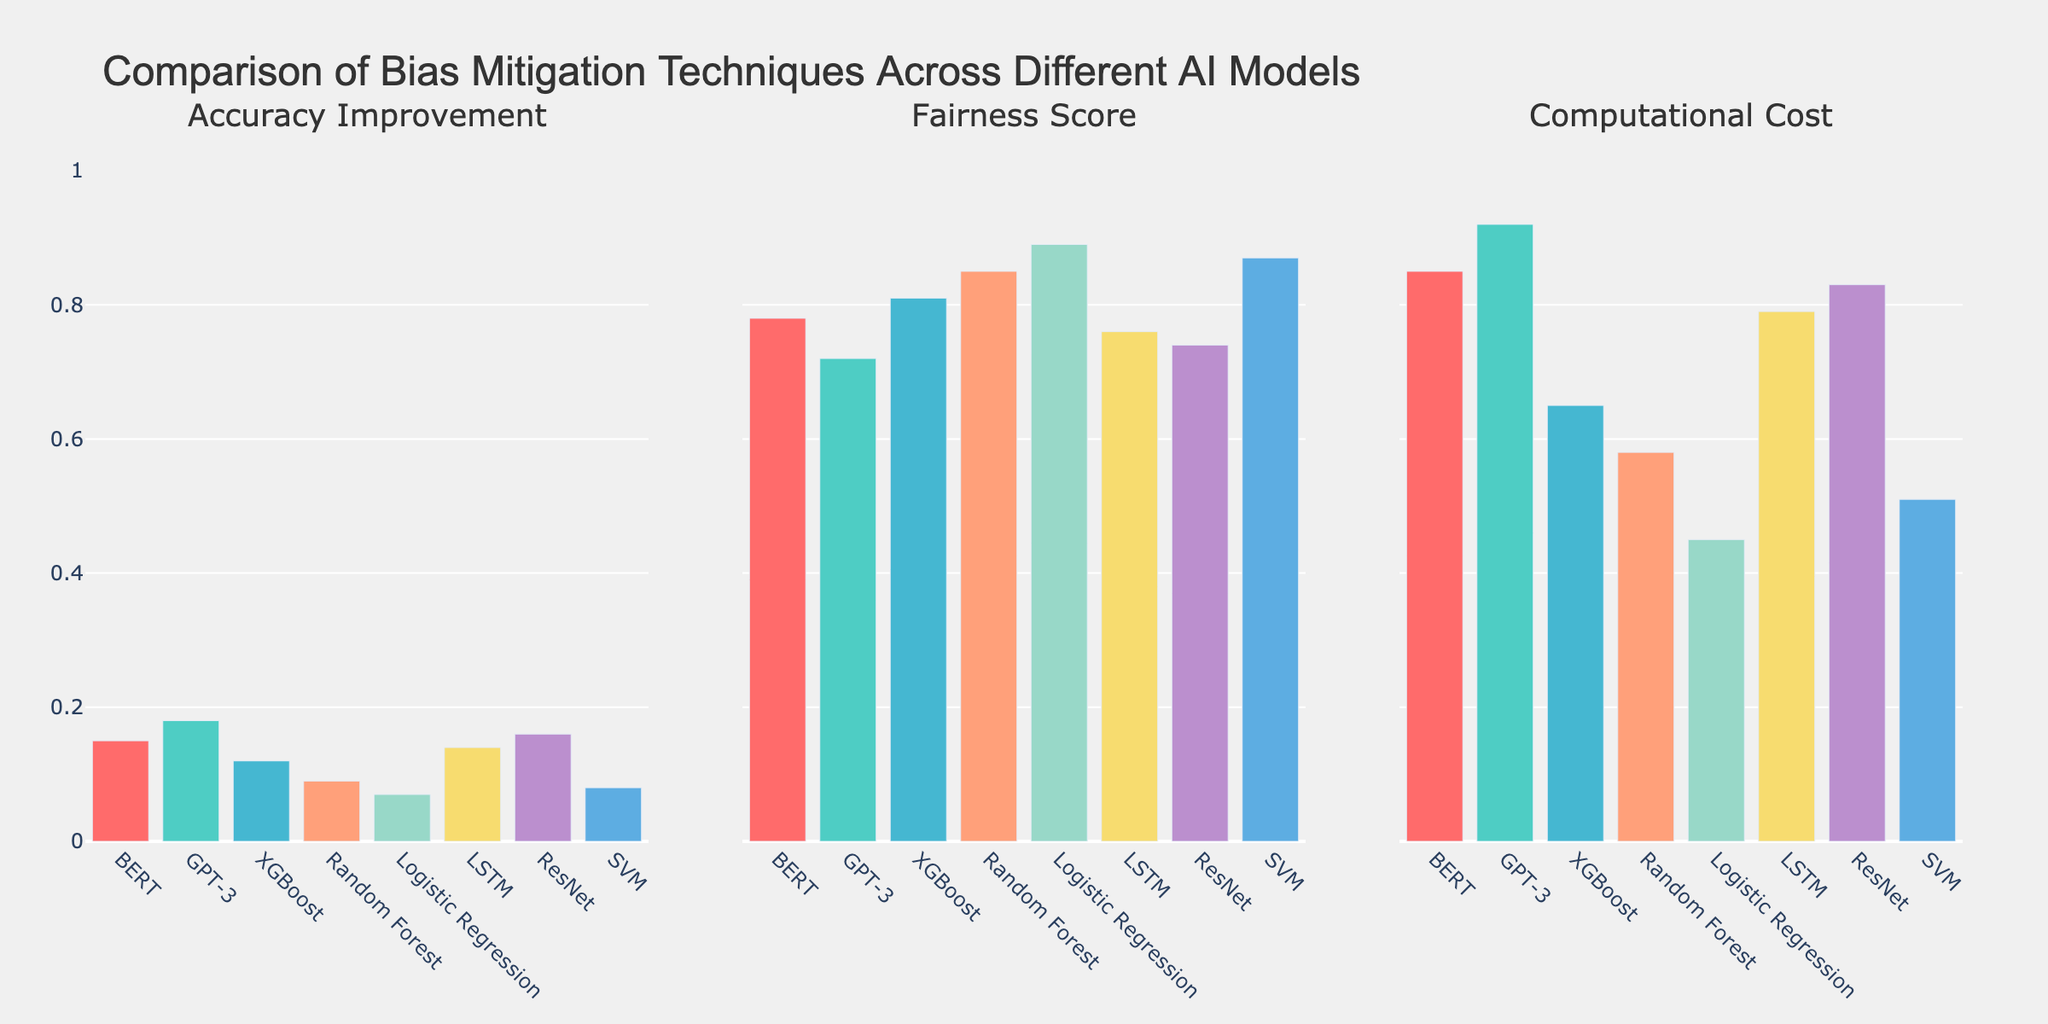Which AI model has the highest accuracy improvement? The BERT, GPT-3, ResNet, and LSTM bars are near the top of the "Accuracy Improvement" subplot. Comparing their heights, GPT-3 has the highest.
Answer: GPT-3 Which model has the lowest computational cost? Looking at the "Computational Cost" subplot, the bar for Logistic Regression is the shortest.
Answer: Logistic Regression How do the fairness scores compare between Logistic Regression and Random Forest? In the "Fairness Score" subplot, the bars for Logistic Regression and Random Forest are the highest and nearly the same, with Logistic Regression slightly higher.
Answer: Logistic Regression slightly higher What is the difference in fairness scores between SVM and BERT? The "Fairness Score" subplot shows that SVM has a fairness score of 0.87, while BERT has 0.78. Subtracting 0.78 from 0.87 gives 0.09.
Answer: 0.09 Which model has a higher accuracy improvement: XGBoost or LSTM? In the "Accuracy Improvement" subplot, the bar for LSTM is taller than that for XGBoost.
Answer: LSTM What is the average computational cost of BERT, GPT-3, and ResNet? The computational costs for BERT, GPT-3, and ResNet are 0.85, 0.92, and 0.83, respectively. The sum is 2.60. Dividing 2.60 by 3 gives approximately 0.867.
Answer: 0.867 What is the total number of models analyzed in the plot? Each subplot contains bars for the same number of models. Counting the bars, there are 8 models.
Answer: 8 Which model has the highest fairness score? The "Fairness Score" subplot shows the highest bar for Logistic Regression.
Answer: Logistic Regression 